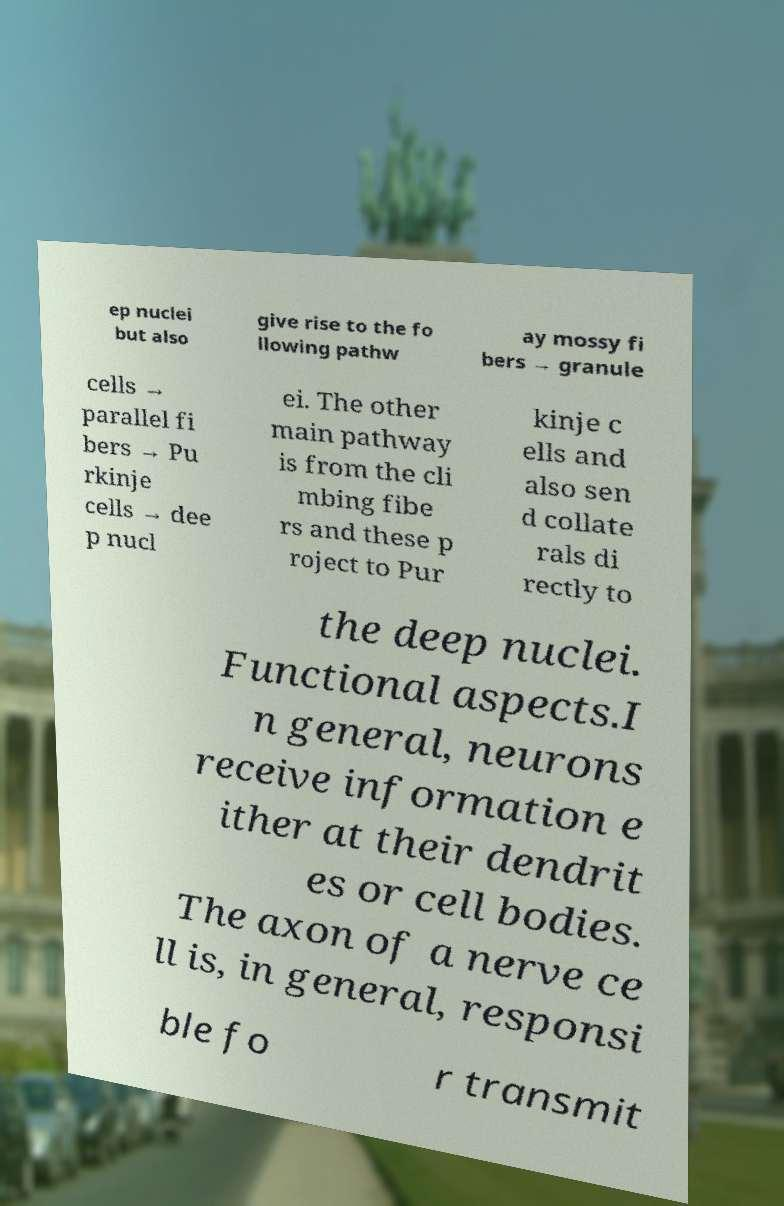Please read and relay the text visible in this image. What does it say? ep nuclei but also give rise to the fo llowing pathw ay mossy fi bers → granule cells → parallel fi bers → Pu rkinje cells → dee p nucl ei. The other main pathway is from the cli mbing fibe rs and these p roject to Pur kinje c ells and also sen d collate rals di rectly to the deep nuclei. Functional aspects.I n general, neurons receive information e ither at their dendrit es or cell bodies. The axon of a nerve ce ll is, in general, responsi ble fo r transmit 